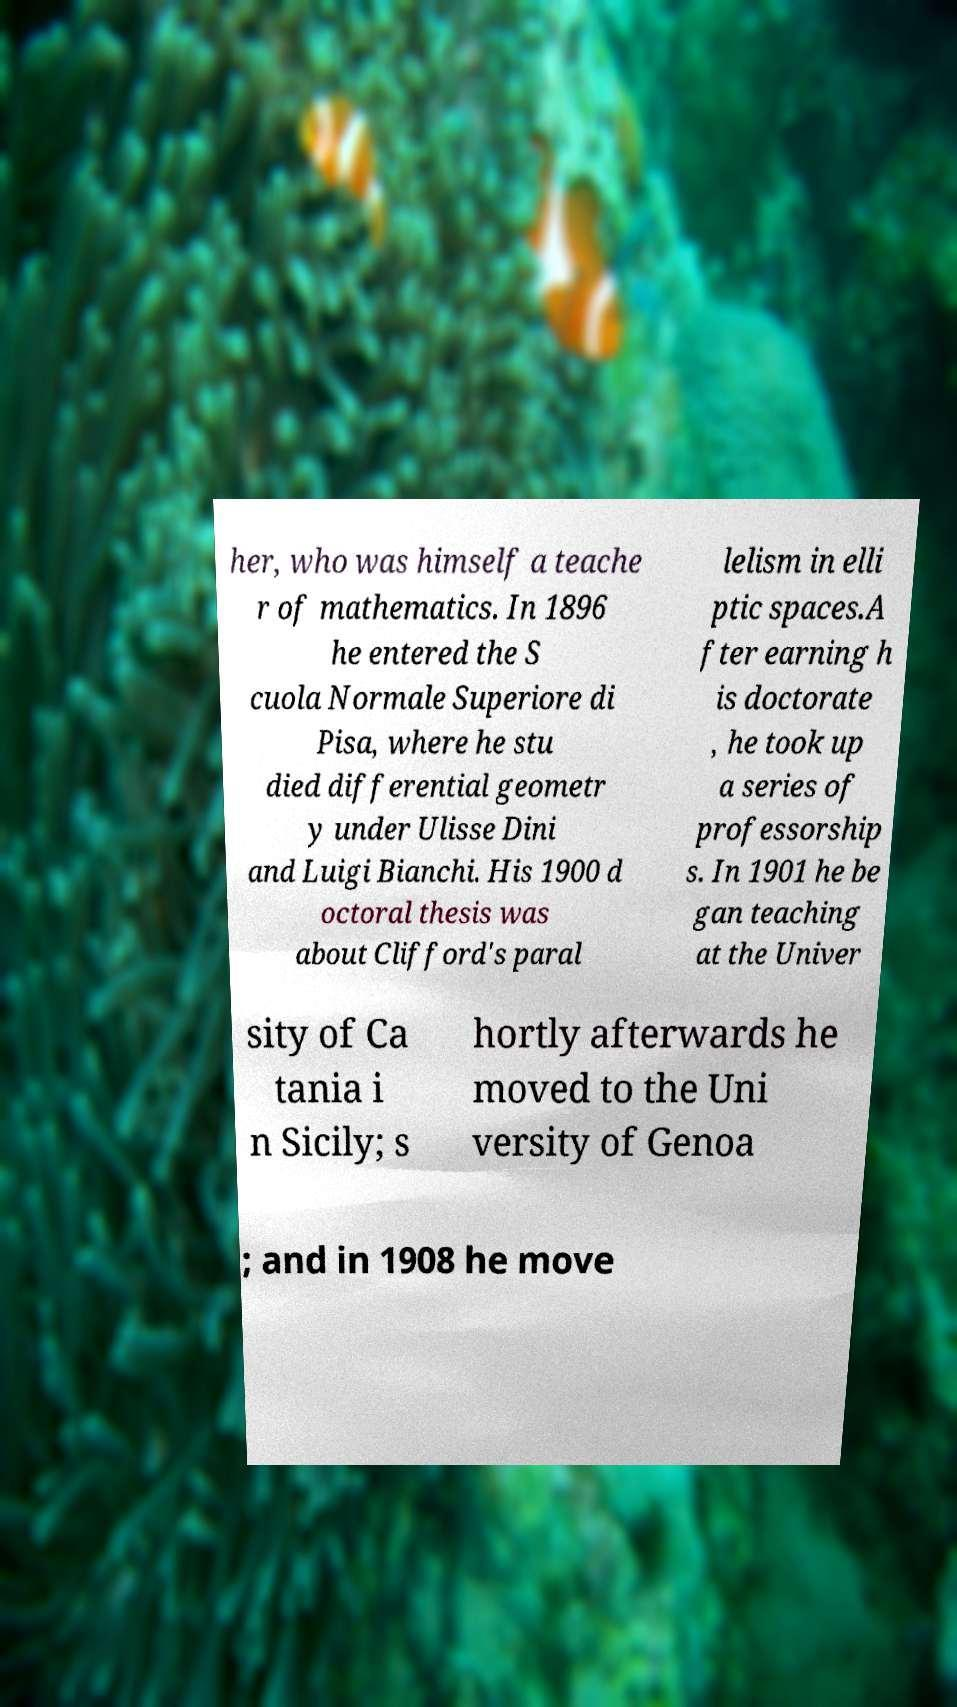What messages or text are displayed in this image? I need them in a readable, typed format. her, who was himself a teache r of mathematics. In 1896 he entered the S cuola Normale Superiore di Pisa, where he stu died differential geometr y under Ulisse Dini and Luigi Bianchi. His 1900 d octoral thesis was about Clifford's paral lelism in elli ptic spaces.A fter earning h is doctorate , he took up a series of professorship s. In 1901 he be gan teaching at the Univer sity of Ca tania i n Sicily; s hortly afterwards he moved to the Uni versity of Genoa ; and in 1908 he move 